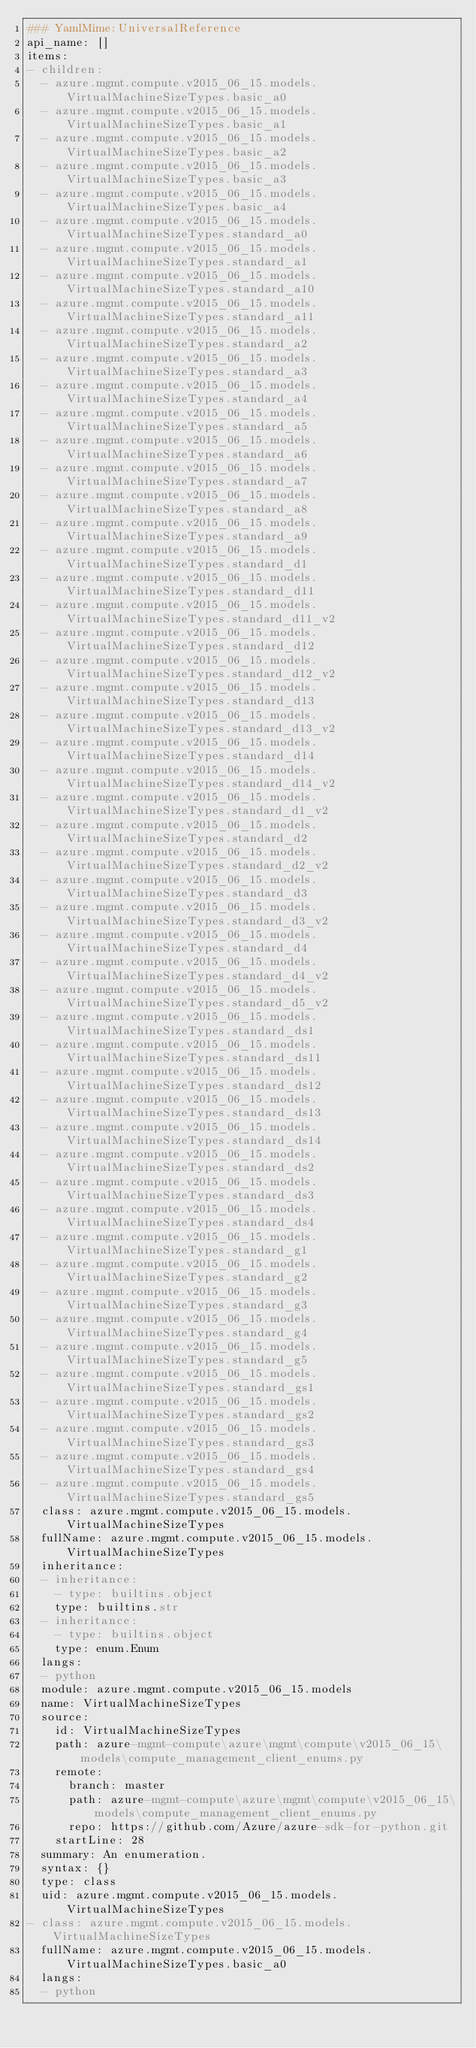<code> <loc_0><loc_0><loc_500><loc_500><_YAML_>### YamlMime:UniversalReference
api_name: []
items:
- children:
  - azure.mgmt.compute.v2015_06_15.models.VirtualMachineSizeTypes.basic_a0
  - azure.mgmt.compute.v2015_06_15.models.VirtualMachineSizeTypes.basic_a1
  - azure.mgmt.compute.v2015_06_15.models.VirtualMachineSizeTypes.basic_a2
  - azure.mgmt.compute.v2015_06_15.models.VirtualMachineSizeTypes.basic_a3
  - azure.mgmt.compute.v2015_06_15.models.VirtualMachineSizeTypes.basic_a4
  - azure.mgmt.compute.v2015_06_15.models.VirtualMachineSizeTypes.standard_a0
  - azure.mgmt.compute.v2015_06_15.models.VirtualMachineSizeTypes.standard_a1
  - azure.mgmt.compute.v2015_06_15.models.VirtualMachineSizeTypes.standard_a10
  - azure.mgmt.compute.v2015_06_15.models.VirtualMachineSizeTypes.standard_a11
  - azure.mgmt.compute.v2015_06_15.models.VirtualMachineSizeTypes.standard_a2
  - azure.mgmt.compute.v2015_06_15.models.VirtualMachineSizeTypes.standard_a3
  - azure.mgmt.compute.v2015_06_15.models.VirtualMachineSizeTypes.standard_a4
  - azure.mgmt.compute.v2015_06_15.models.VirtualMachineSizeTypes.standard_a5
  - azure.mgmt.compute.v2015_06_15.models.VirtualMachineSizeTypes.standard_a6
  - azure.mgmt.compute.v2015_06_15.models.VirtualMachineSizeTypes.standard_a7
  - azure.mgmt.compute.v2015_06_15.models.VirtualMachineSizeTypes.standard_a8
  - azure.mgmt.compute.v2015_06_15.models.VirtualMachineSizeTypes.standard_a9
  - azure.mgmt.compute.v2015_06_15.models.VirtualMachineSizeTypes.standard_d1
  - azure.mgmt.compute.v2015_06_15.models.VirtualMachineSizeTypes.standard_d11
  - azure.mgmt.compute.v2015_06_15.models.VirtualMachineSizeTypes.standard_d11_v2
  - azure.mgmt.compute.v2015_06_15.models.VirtualMachineSizeTypes.standard_d12
  - azure.mgmt.compute.v2015_06_15.models.VirtualMachineSizeTypes.standard_d12_v2
  - azure.mgmt.compute.v2015_06_15.models.VirtualMachineSizeTypes.standard_d13
  - azure.mgmt.compute.v2015_06_15.models.VirtualMachineSizeTypes.standard_d13_v2
  - azure.mgmt.compute.v2015_06_15.models.VirtualMachineSizeTypes.standard_d14
  - azure.mgmt.compute.v2015_06_15.models.VirtualMachineSizeTypes.standard_d14_v2
  - azure.mgmt.compute.v2015_06_15.models.VirtualMachineSizeTypes.standard_d1_v2
  - azure.mgmt.compute.v2015_06_15.models.VirtualMachineSizeTypes.standard_d2
  - azure.mgmt.compute.v2015_06_15.models.VirtualMachineSizeTypes.standard_d2_v2
  - azure.mgmt.compute.v2015_06_15.models.VirtualMachineSizeTypes.standard_d3
  - azure.mgmt.compute.v2015_06_15.models.VirtualMachineSizeTypes.standard_d3_v2
  - azure.mgmt.compute.v2015_06_15.models.VirtualMachineSizeTypes.standard_d4
  - azure.mgmt.compute.v2015_06_15.models.VirtualMachineSizeTypes.standard_d4_v2
  - azure.mgmt.compute.v2015_06_15.models.VirtualMachineSizeTypes.standard_d5_v2
  - azure.mgmt.compute.v2015_06_15.models.VirtualMachineSizeTypes.standard_ds1
  - azure.mgmt.compute.v2015_06_15.models.VirtualMachineSizeTypes.standard_ds11
  - azure.mgmt.compute.v2015_06_15.models.VirtualMachineSizeTypes.standard_ds12
  - azure.mgmt.compute.v2015_06_15.models.VirtualMachineSizeTypes.standard_ds13
  - azure.mgmt.compute.v2015_06_15.models.VirtualMachineSizeTypes.standard_ds14
  - azure.mgmt.compute.v2015_06_15.models.VirtualMachineSizeTypes.standard_ds2
  - azure.mgmt.compute.v2015_06_15.models.VirtualMachineSizeTypes.standard_ds3
  - azure.mgmt.compute.v2015_06_15.models.VirtualMachineSizeTypes.standard_ds4
  - azure.mgmt.compute.v2015_06_15.models.VirtualMachineSizeTypes.standard_g1
  - azure.mgmt.compute.v2015_06_15.models.VirtualMachineSizeTypes.standard_g2
  - azure.mgmt.compute.v2015_06_15.models.VirtualMachineSizeTypes.standard_g3
  - azure.mgmt.compute.v2015_06_15.models.VirtualMachineSizeTypes.standard_g4
  - azure.mgmt.compute.v2015_06_15.models.VirtualMachineSizeTypes.standard_g5
  - azure.mgmt.compute.v2015_06_15.models.VirtualMachineSizeTypes.standard_gs1
  - azure.mgmt.compute.v2015_06_15.models.VirtualMachineSizeTypes.standard_gs2
  - azure.mgmt.compute.v2015_06_15.models.VirtualMachineSizeTypes.standard_gs3
  - azure.mgmt.compute.v2015_06_15.models.VirtualMachineSizeTypes.standard_gs4
  - azure.mgmt.compute.v2015_06_15.models.VirtualMachineSizeTypes.standard_gs5
  class: azure.mgmt.compute.v2015_06_15.models.VirtualMachineSizeTypes
  fullName: azure.mgmt.compute.v2015_06_15.models.VirtualMachineSizeTypes
  inheritance:
  - inheritance:
    - type: builtins.object
    type: builtins.str
  - inheritance:
    - type: builtins.object
    type: enum.Enum
  langs:
  - python
  module: azure.mgmt.compute.v2015_06_15.models
  name: VirtualMachineSizeTypes
  source:
    id: VirtualMachineSizeTypes
    path: azure-mgmt-compute\azure\mgmt\compute\v2015_06_15\models\compute_management_client_enums.py
    remote:
      branch: master
      path: azure-mgmt-compute\azure\mgmt\compute\v2015_06_15\models\compute_management_client_enums.py
      repo: https://github.com/Azure/azure-sdk-for-python.git
    startLine: 28
  summary: An enumeration.
  syntax: {}
  type: class
  uid: azure.mgmt.compute.v2015_06_15.models.VirtualMachineSizeTypes
- class: azure.mgmt.compute.v2015_06_15.models.VirtualMachineSizeTypes
  fullName: azure.mgmt.compute.v2015_06_15.models.VirtualMachineSizeTypes.basic_a0
  langs:
  - python</code> 